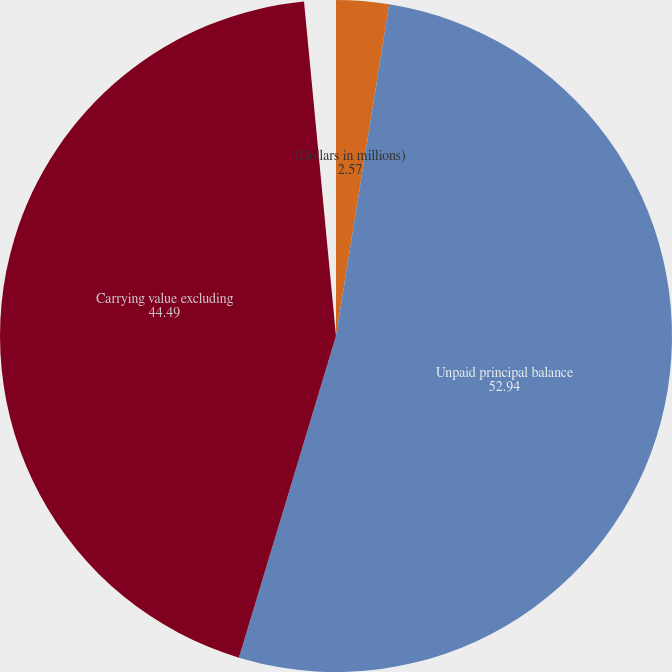Convert chart to OTSL. <chart><loc_0><loc_0><loc_500><loc_500><pie_chart><fcel>(Dollars in millions)<fcel>Unpaid principal balance<fcel>Carrying value excluding<nl><fcel>2.57%<fcel>52.94%<fcel>44.49%<nl></chart> 